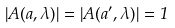<formula> <loc_0><loc_0><loc_500><loc_500>\left | A ( a , \lambda ) \right | = \left | A ( a ^ { \prime } , \lambda ) \right | = 1</formula> 